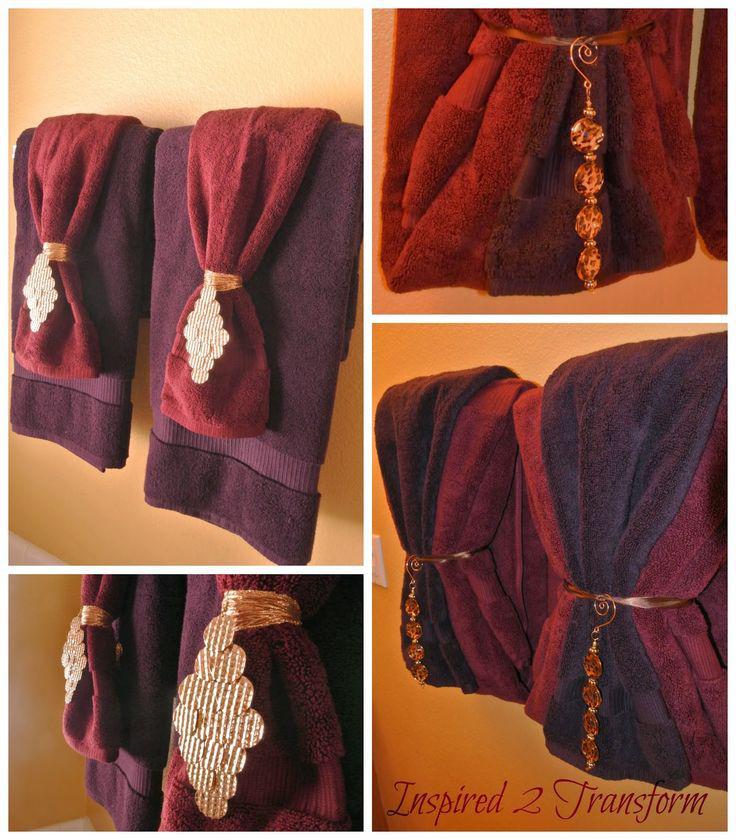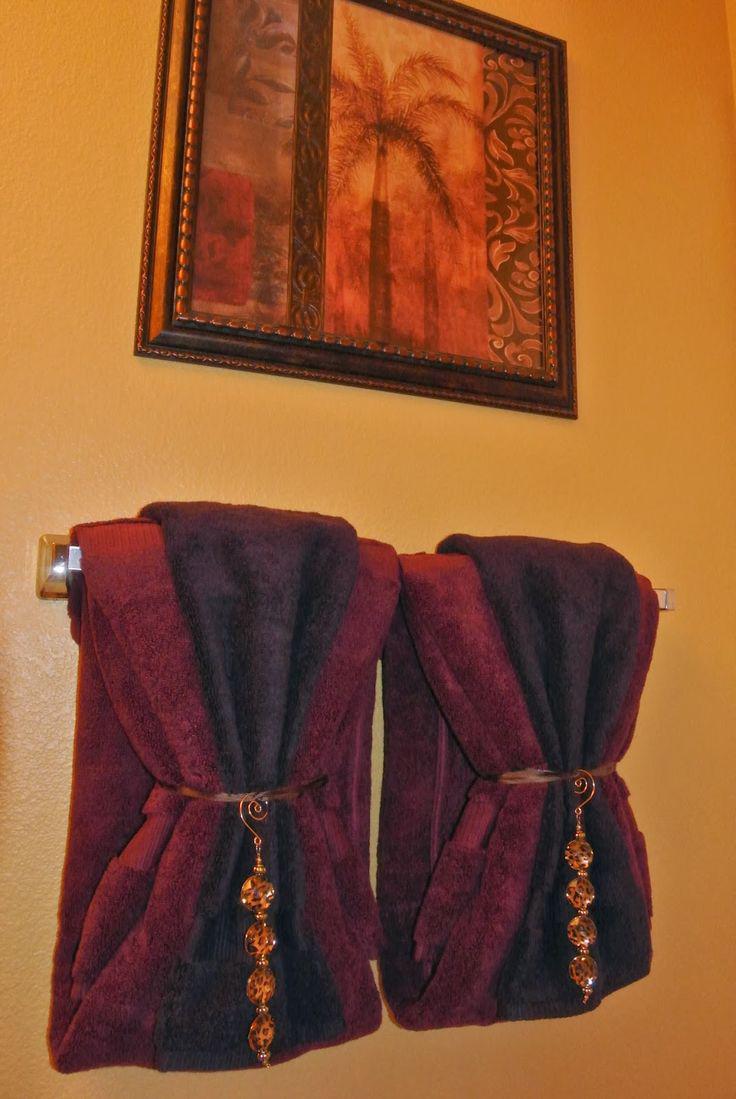The first image is the image on the left, the second image is the image on the right. Assess this claim about the two images: "Towels are hung on the wall under pictures.". Correct or not? Answer yes or no. Yes. 